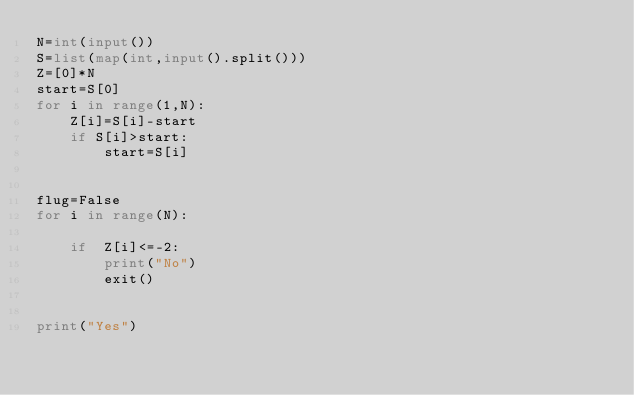<code> <loc_0><loc_0><loc_500><loc_500><_Python_>N=int(input())
S=list(map(int,input().split()))
Z=[0]*N
start=S[0]
for i in range(1,N):
    Z[i]=S[i]-start
    if S[i]>start:
        start=S[i]


flug=False
for i in range(N):
    
    if  Z[i]<=-2:
        print("No")
        exit()
        

print("Yes")</code> 